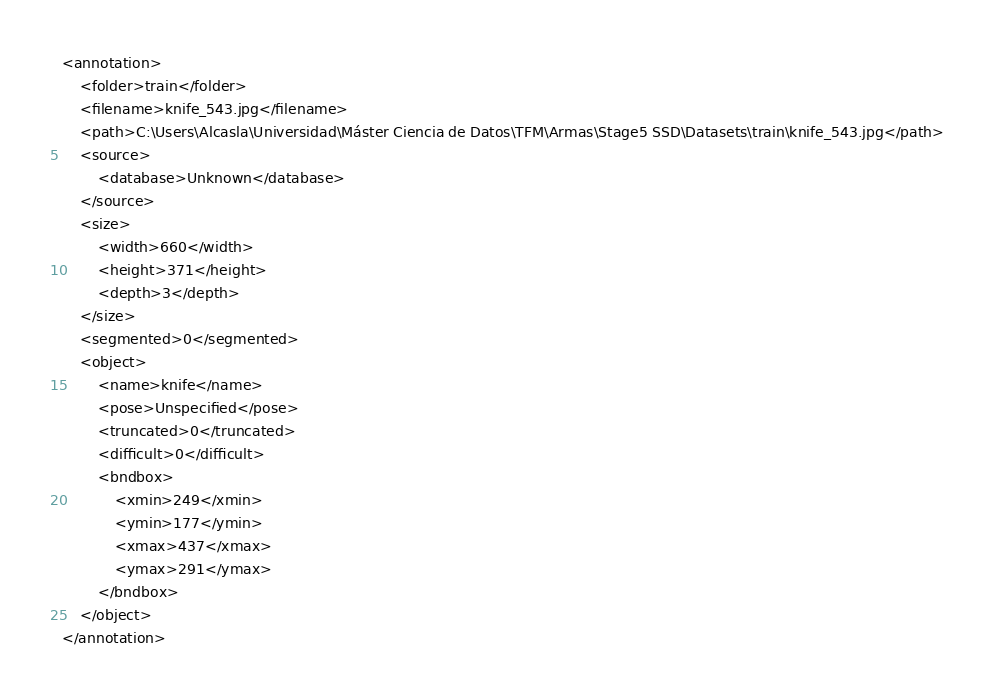<code> <loc_0><loc_0><loc_500><loc_500><_XML_><annotation>
	<folder>train</folder>
	<filename>knife_543.jpg</filename>
	<path>C:\Users\Alcasla\Universidad\Máster Ciencia de Datos\TFM\Armas\Stage5 SSD\Datasets\train\knife_543.jpg</path>
	<source>
		<database>Unknown</database>
	</source>
	<size>
		<width>660</width>
		<height>371</height>
		<depth>3</depth>
	</size>
	<segmented>0</segmented>
	<object>
		<name>knife</name>
		<pose>Unspecified</pose>
		<truncated>0</truncated>
		<difficult>0</difficult>
		<bndbox>
			<xmin>249</xmin>
			<ymin>177</ymin>
			<xmax>437</xmax>
			<ymax>291</ymax>
		</bndbox>
	</object>
</annotation>
</code> 